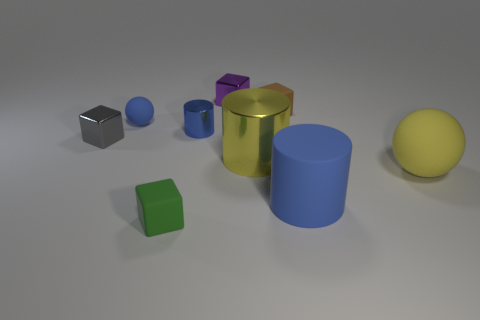Which object stands out the most in this arrangement and why? The golden cylinder stands out the most due to its reflective surface and vibrant color, which contrasts sharply with the matte surfaces and more subdued colors of the surrounding objects. 